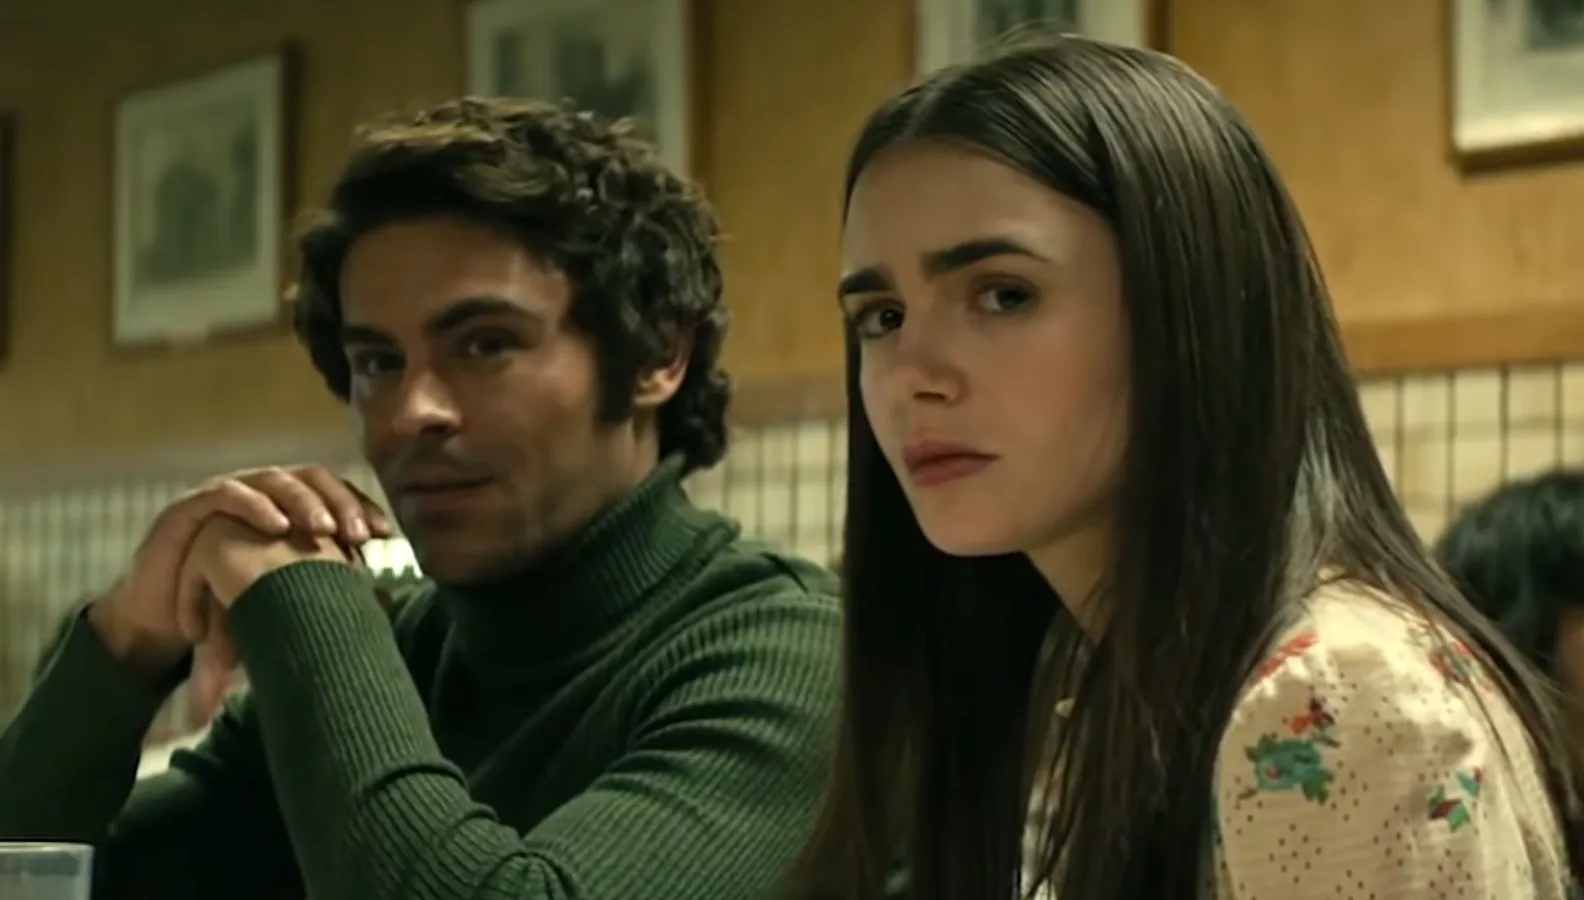Explain the visual content of the image in great detail. This image depicts two actors portraying a scene inside a cozy diner setting. On the left side of the frame, we see a man with curly brown hair wearing a green turtleneck sweater. He is leaning forward slightly, with his hands clasped in front of him and his chin resting on his hands. His expression is calm and introspective, and his gaze is directed towards the unseen person or object on the right side of the frame. The background shows a wall decorated with framed pictures and a checkered design beneath them, adding to the diner’s nostalgic atmosphere. On the right side of the image, a woman with long, straight hair is seated. She is wearing a cream-colored blouse with a delicate floral pattern, bringing a touch of softness to the scene. Her expression appears serious and contemplative, adding a layer of intensity and depth to the dialogue likely unfolding between the two characters. Both of their expressions and body language suggest an intense and possibly emotional exchange, situated in a quintessentially American diner. 